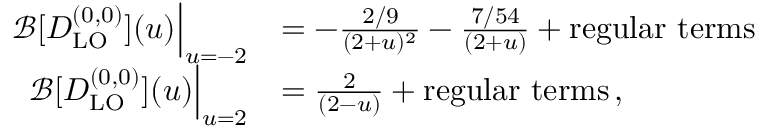Convert formula to latex. <formula><loc_0><loc_0><loc_500><loc_500>\begin{array} { r l } { \mathcal { B } [ D _ { L O } ^ { ( 0 , 0 ) } ] ( u ) \left | _ { u = - 2 } } & { = - \frac { 2 / 9 } { ( 2 + u ) ^ { 2 } } - \frac { 7 / 5 4 } { ( 2 + u ) } + r e g u l a r t e r m s } \\ { \mathcal { B } [ D _ { L O } ^ { ( 0 , 0 ) } ] ( u ) \right | _ { u = 2 } } & { = \frac { 2 } { ( 2 - u ) } + r e g u l a r t e r m s \, , } \end{array}</formula> 